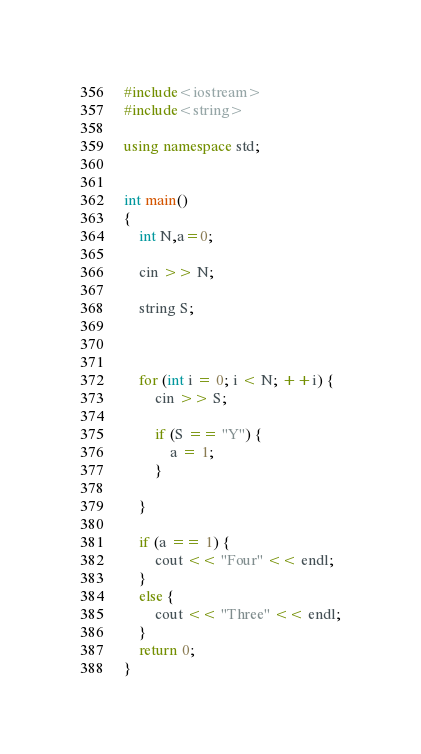<code> <loc_0><loc_0><loc_500><loc_500><_C++_>#include<iostream>
#include<string>

using namespace std;


int main()
{
	int N,a=0;

	cin >> N;

	string S;



	for (int i = 0; i < N; ++i) {
		cin >> S;

		if (S == "Y") {
			a = 1;
		}

	}

	if (a == 1) {
		cout << "Four" << endl;
	}
	else {
		cout << "Three" << endl;
	}
    return 0;
}</code> 